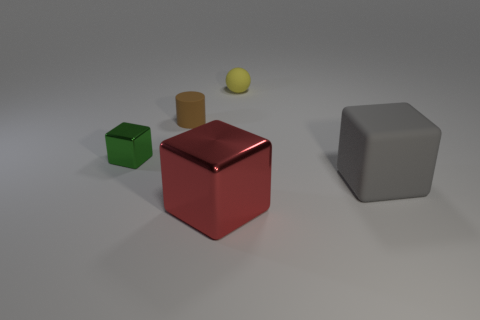Add 3 brown cylinders. How many objects exist? 8 Subtract all cylinders. How many objects are left? 4 Add 5 shiny things. How many shiny things are left? 7 Add 3 yellow metal cubes. How many yellow metal cubes exist? 3 Subtract 1 yellow balls. How many objects are left? 4 Subtract all rubber spheres. Subtract all large blue spheres. How many objects are left? 4 